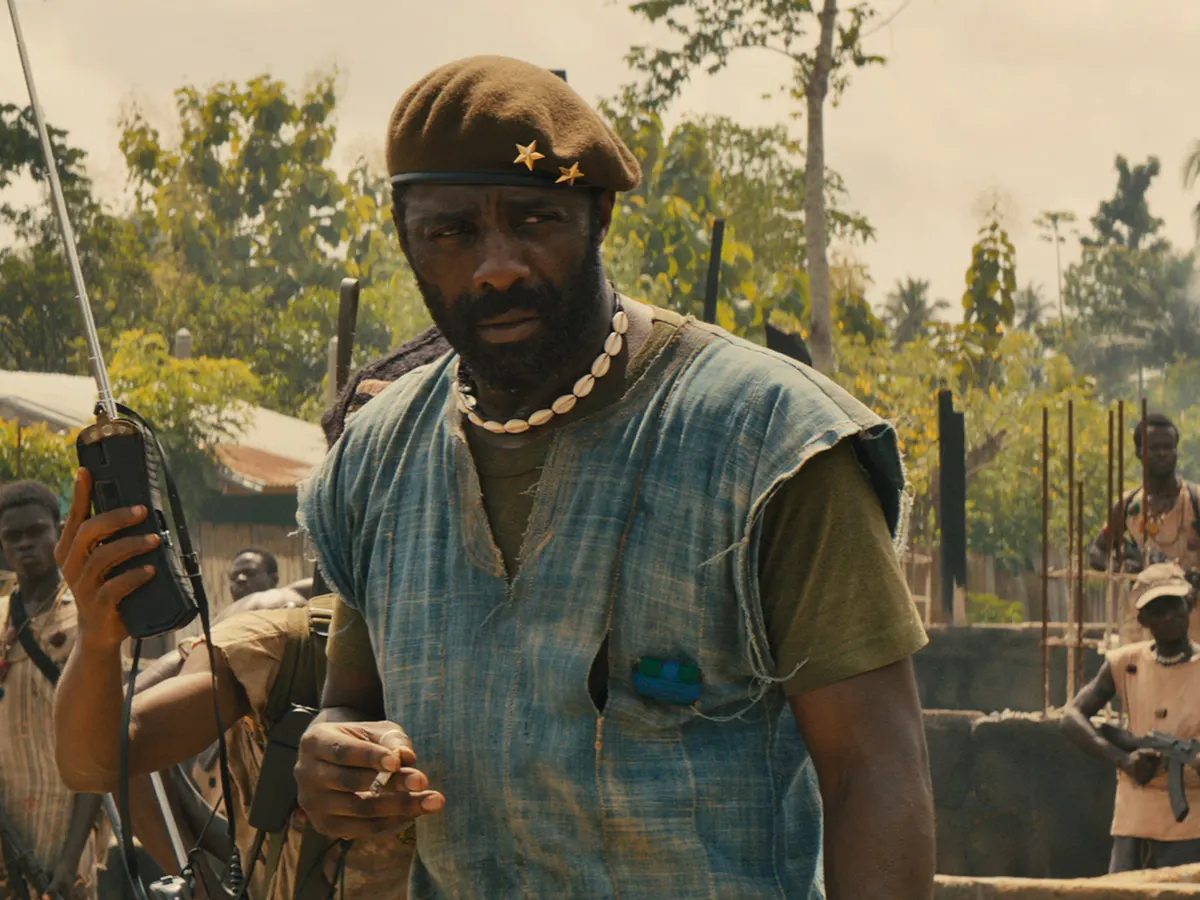Can you elaborate on the elements of the picture provided? In this image, we see the actor Idris Elba portraying the character Commandant from the movie 'Beasts of No Nation'. He is positioned in a dusty, war-torn village, appearing to issue commands. His attire includes a blue sleeveless shirt layered with a green vest, and he dons a green beret with a gold star. In his right hand, he holds a walkie-talkie, while a gun is slung over his left shoulder. Surrounding him are soldiers attentively listening to his orders, highlighting his authoritative role within the scene. The background shows a village with basic structures and light vegetation, reflecting the harsh and unstable environment. 